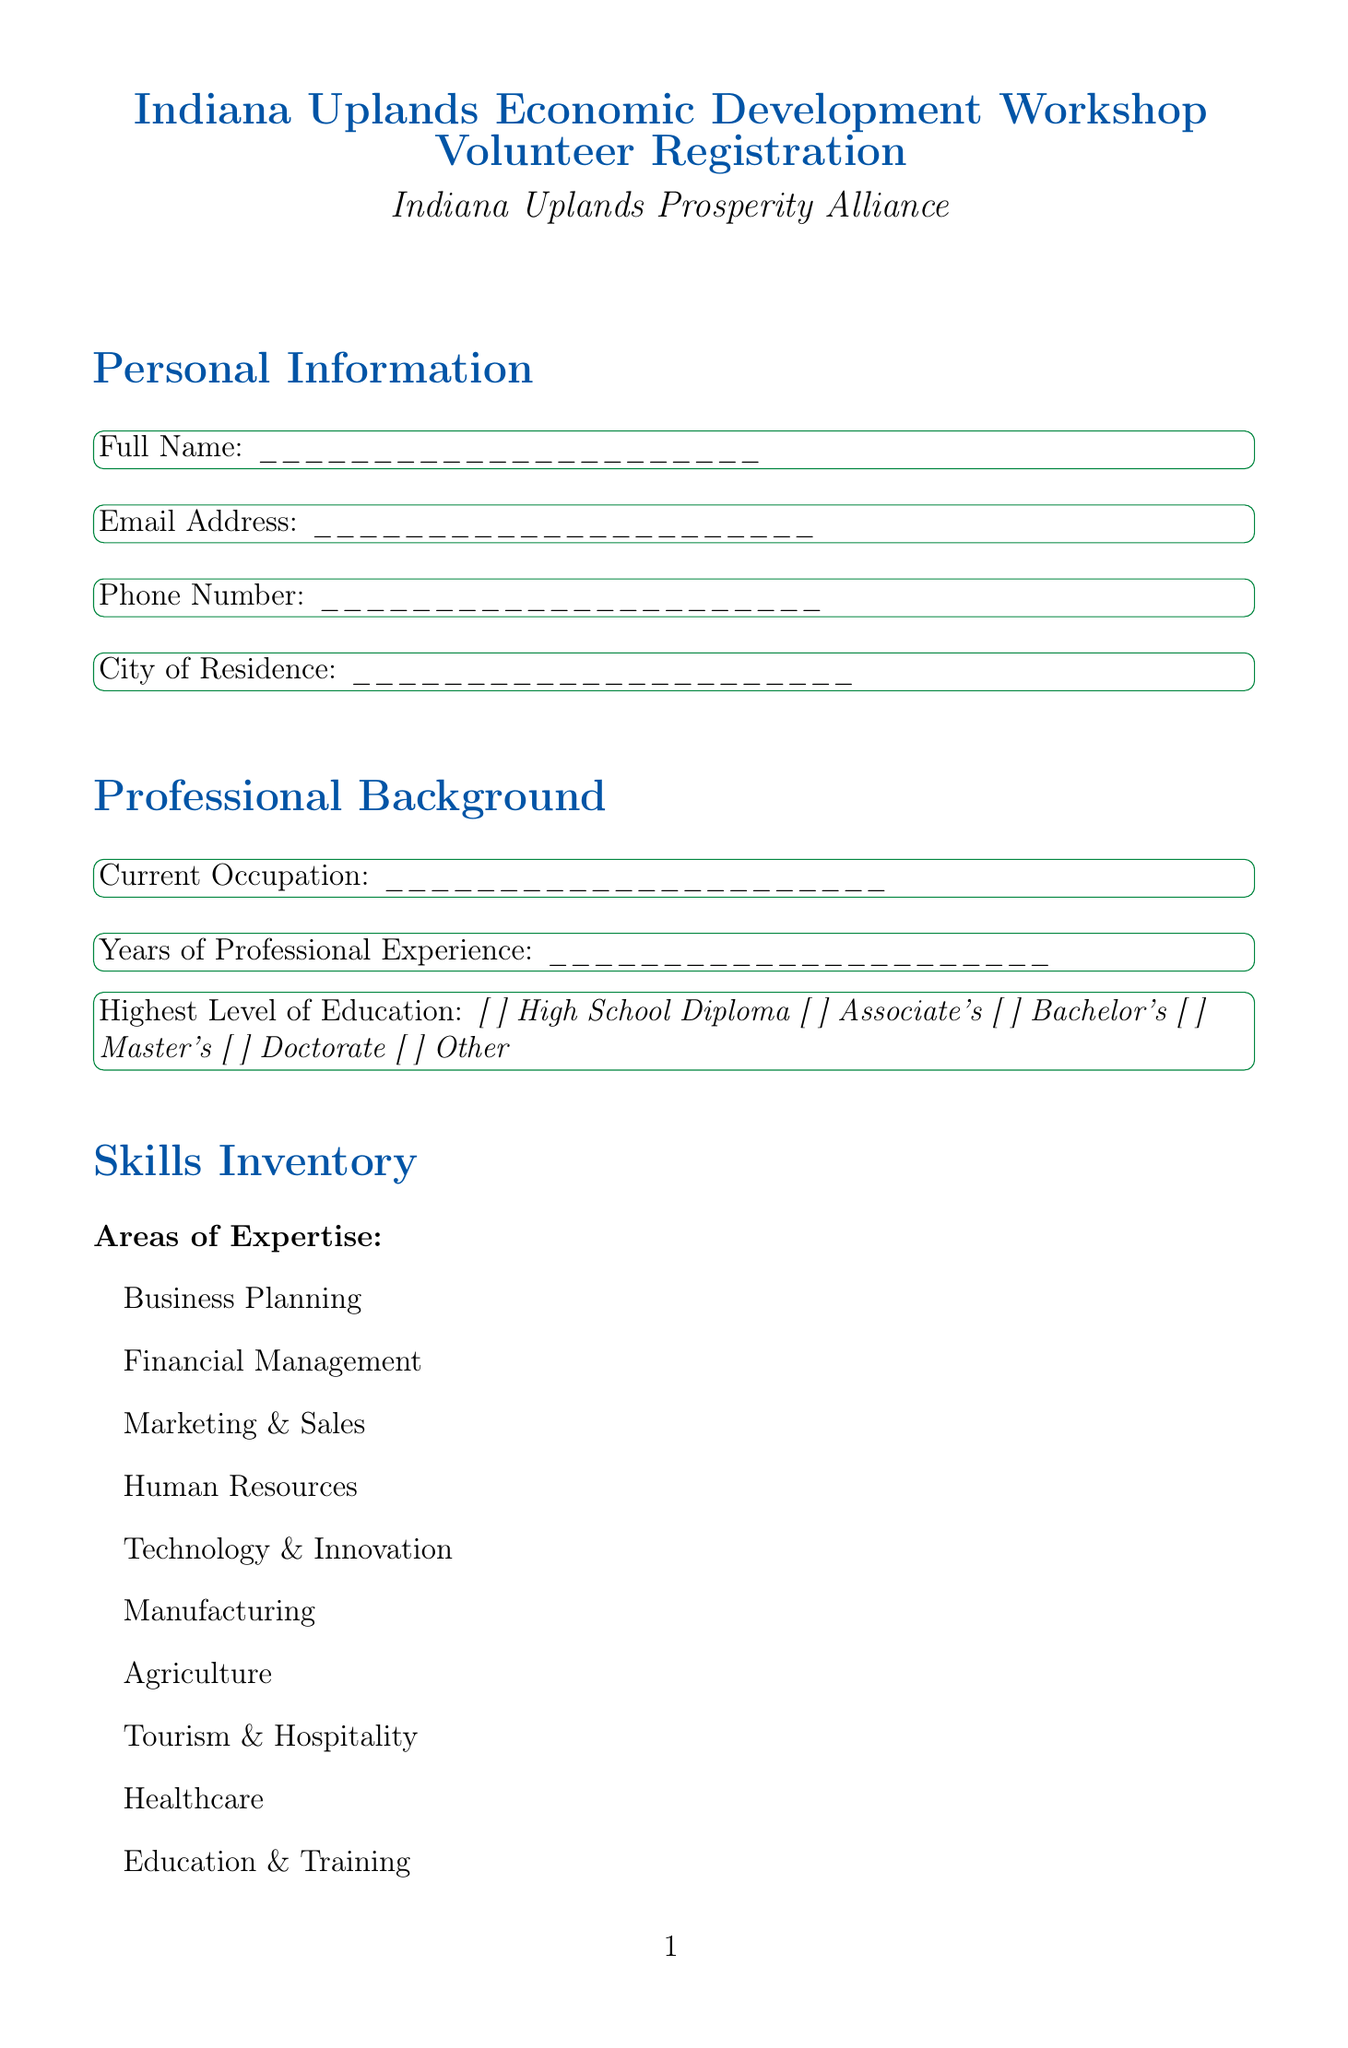What is the title of the document? The title of the document is presented at the top of the form as the main heading.
Answer: Indiana Uplands Economic Development Workshop Volunteer Registration Who is the organization behind the form? The name of the organization is mentioned directly under the title of the form.
Answer: Indiana Uplands Prosperity Alliance What is the maximum education level option listed in the document? The highest level of education available in the dropdown options is provided among multiple choices.
Answer: Doctorate What languages are included in the language skills section? The document lists options for language skills, including several languages from which respondents can choose.
Answer: English, Spanish, Mandarin, French, German, Other How many areas of expertise can volunteers select? The areas of expertise are listed as checkboxes, and the total count of these options indicates how many can be selected by volunteers.
Answer: Ten What is the frequency of volunteering option that allows flexibility? The frequency section offers multiple choices for how often volunteers prefer to serve.
Answer: As needed Which workshop topic focuses on local marketing strategies? The workshop preferences contain various topics related to economic development, one of which specifically covers local marketing.
Answer: Digital Marketing for Local Businesses What consent is required regarding the volunteer code of conduct? The consent and agreement section includes an option related to adhering to conduct guidelines.
Answer: I agree to abide by the Indiana Uplands Prosperity Alliance volunteer code of conduct How did the document suggest participants might hear about the volunteer program? There is a dropdown to provide how volunteers were informed about the program, indicating multiple sources.
Answer: Indiana Uplands website, Social media, Friend or colleague, Local news, Community event, Other 